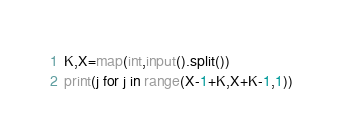<code> <loc_0><loc_0><loc_500><loc_500><_Python_>K,X=map(int,input().split())
print(j for j in range(X-1+K,X+K-1,1))</code> 